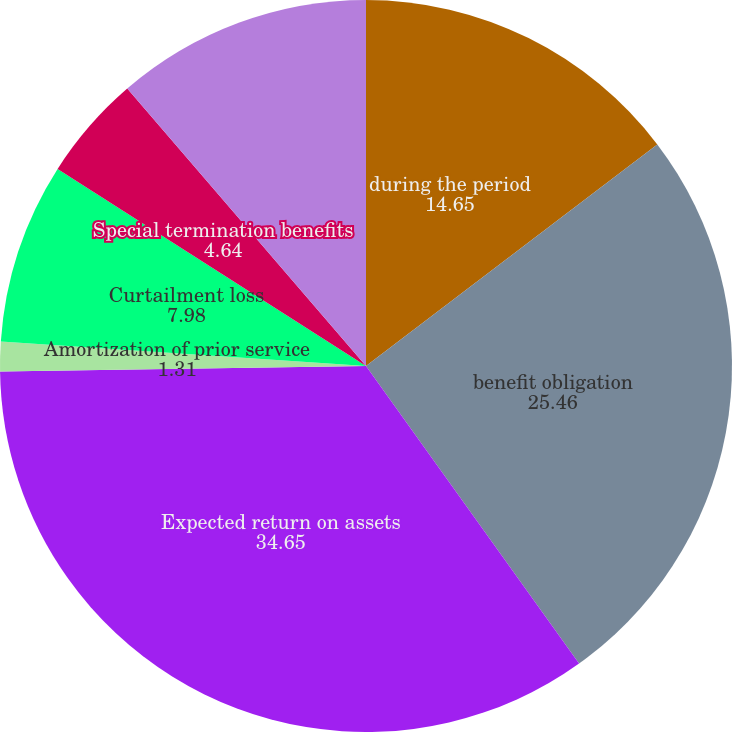Convert chart. <chart><loc_0><loc_0><loc_500><loc_500><pie_chart><fcel>during the period<fcel>benefit obligation<fcel>Expected return on assets<fcel>Amortization of prior service<fcel>Curtailment loss<fcel>Special termination benefits<fcel>Net pension cost<nl><fcel>14.65%<fcel>25.46%<fcel>34.65%<fcel>1.31%<fcel>7.98%<fcel>4.64%<fcel>11.31%<nl></chart> 